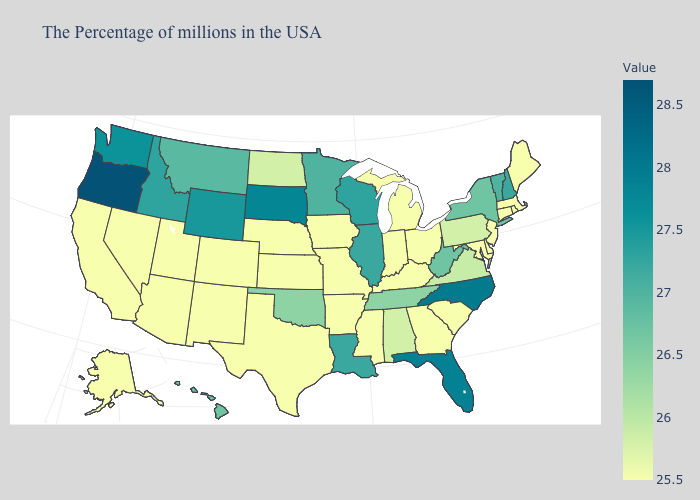Among the states that border South Dakota , does Iowa have the highest value?
Keep it brief. No. Which states have the lowest value in the MidWest?
Give a very brief answer. Ohio, Michigan, Indiana, Missouri, Iowa, Kansas, Nebraska. Does Texas have a higher value than Florida?
Short answer required. No. 